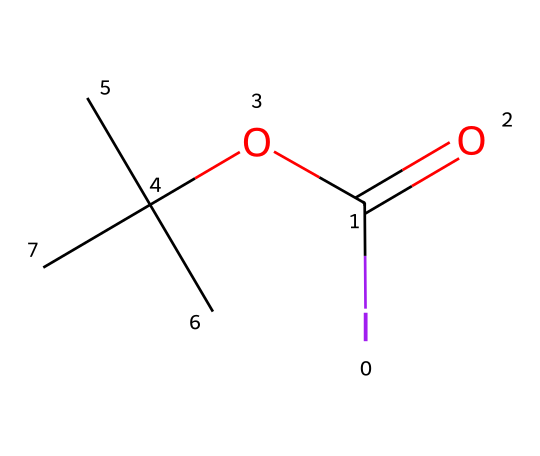What is the central atom in this hypervalent compound? Looking at the SMILES representation, the central atom connected to the highest number of other atoms is iodine (I).
Answer: iodine How many carbon atoms are present in this compound? The SMILES indicates there are four carbon atoms (C) present. This is evident from the way carbon is repeated in the structure.
Answer: four What functional group is present in this chemical structure? The presence of the “C(=O)” in the SMILES indicates a carbonyl group (C=O), which is characteristic of esters or carboxylic acids.
Answer: carbonyl How many total atoms are in the compound? Counting all the atoms in SMILES yields a total of 8: 1 iodine, 4 carbons, 8 hydrogens, and 1 oxygen, making a total of 8 atoms.
Answer: eight Which atom in this compound exhibits hypervalency? The iodine atom is connected to more than four other atoms, which classifies it as hypervalent due to its ability to expand its valence shell.
Answer: iodine What property could the presence of iodine confer to this compound regarding fuel additives? Iodine can enhance the combustion efficiency of fuels, making the presence of iodine important in automotive fuel additives.
Answer: combustion efficiency Is this compound likely to participate in a nucleophilic reaction? Due to the presence of the carbonyl functional group which has electron-withdrawing effects, the compound is likely to be electrophilic, enabling it to participate in nucleophilic reactions.
Answer: yes 